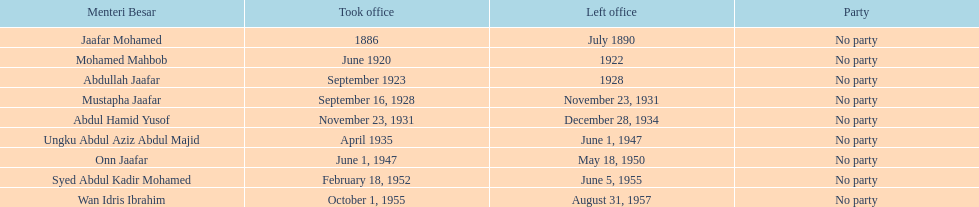Name someone who was not in office more than 4 years. Mohamed Mahbob. 